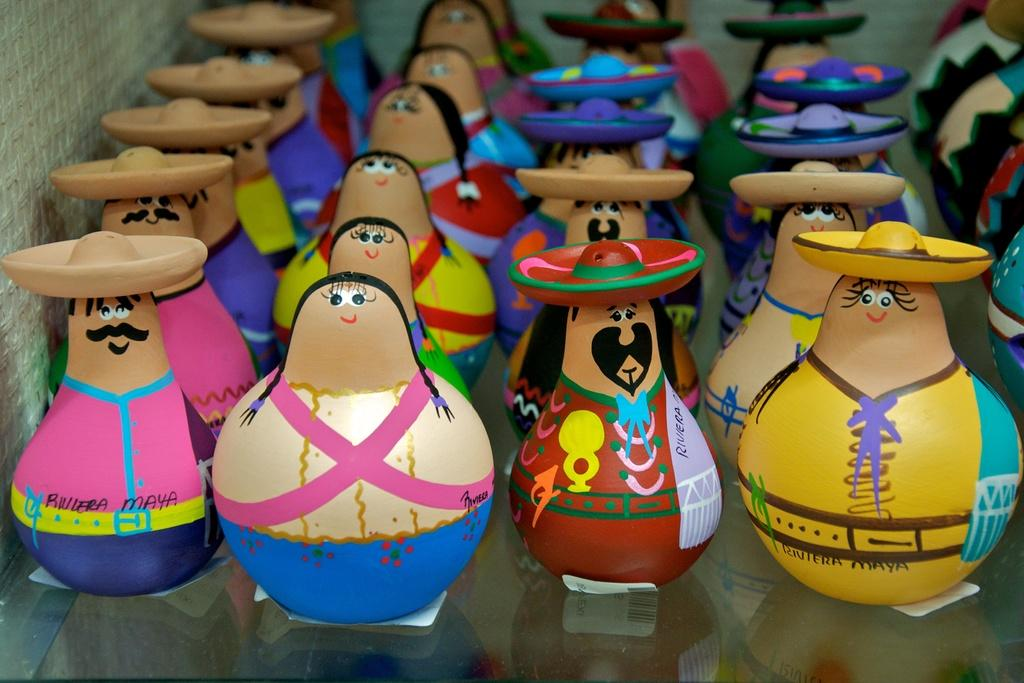What objects are on the glass in the image? There are toys on the glass in the image. What can be seen on the left side of the image? There is a wall on the left side of the image. What type of pickle is being transported to the heat source in the image? There is no pickle, transportation, or heat source present in the image. 